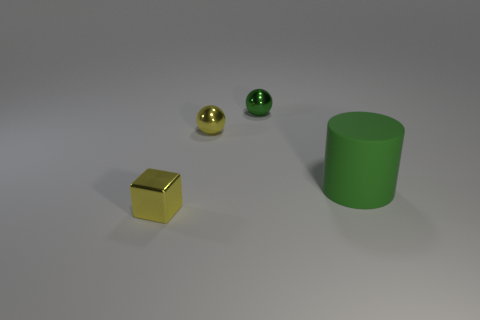How many objects are gray metallic spheres or yellow shiny spheres to the left of the big green cylinder? 1 